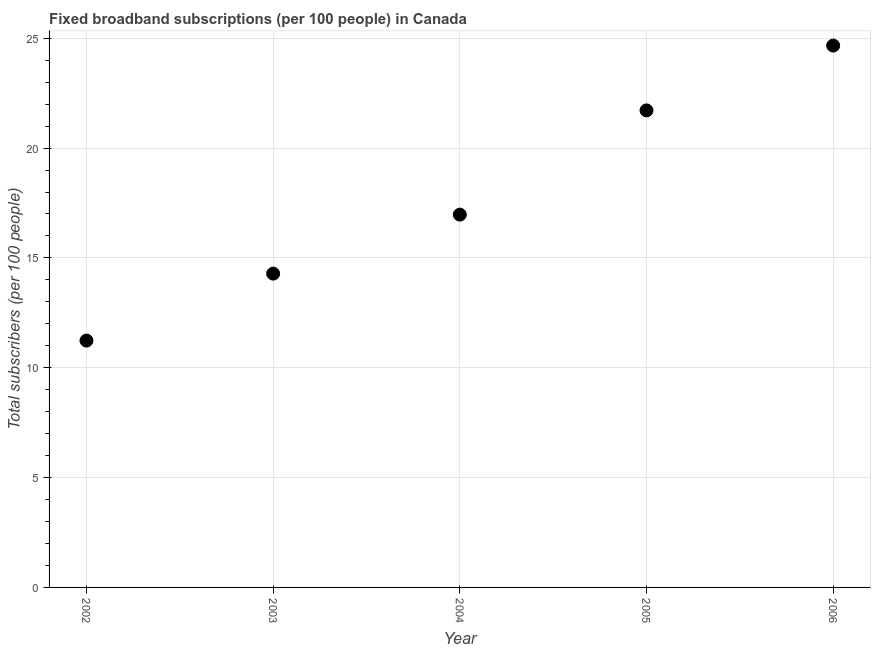What is the total number of fixed broadband subscriptions in 2003?
Your answer should be very brief. 14.29. Across all years, what is the maximum total number of fixed broadband subscriptions?
Keep it short and to the point. 24.67. Across all years, what is the minimum total number of fixed broadband subscriptions?
Offer a very short reply. 11.24. In which year was the total number of fixed broadband subscriptions maximum?
Offer a very short reply. 2006. What is the sum of the total number of fixed broadband subscriptions?
Make the answer very short. 88.87. What is the difference between the total number of fixed broadband subscriptions in 2002 and 2005?
Your answer should be compact. -10.48. What is the average total number of fixed broadband subscriptions per year?
Your response must be concise. 17.77. What is the median total number of fixed broadband subscriptions?
Provide a short and direct response. 16.97. Do a majority of the years between 2003 and 2005 (inclusive) have total number of fixed broadband subscriptions greater than 20 ?
Keep it short and to the point. No. What is the ratio of the total number of fixed broadband subscriptions in 2002 to that in 2003?
Your answer should be compact. 0.79. Is the total number of fixed broadband subscriptions in 2002 less than that in 2006?
Provide a short and direct response. Yes. Is the difference between the total number of fixed broadband subscriptions in 2002 and 2005 greater than the difference between any two years?
Give a very brief answer. No. What is the difference between the highest and the second highest total number of fixed broadband subscriptions?
Keep it short and to the point. 2.95. What is the difference between the highest and the lowest total number of fixed broadband subscriptions?
Offer a terse response. 13.43. In how many years, is the total number of fixed broadband subscriptions greater than the average total number of fixed broadband subscriptions taken over all years?
Offer a terse response. 2. Does the total number of fixed broadband subscriptions monotonically increase over the years?
Keep it short and to the point. Yes. How many years are there in the graph?
Make the answer very short. 5. What is the difference between two consecutive major ticks on the Y-axis?
Your answer should be very brief. 5. Are the values on the major ticks of Y-axis written in scientific E-notation?
Provide a short and direct response. No. Does the graph contain any zero values?
Offer a very short reply. No. Does the graph contain grids?
Your answer should be compact. Yes. What is the title of the graph?
Offer a terse response. Fixed broadband subscriptions (per 100 people) in Canada. What is the label or title of the Y-axis?
Your response must be concise. Total subscribers (per 100 people). What is the Total subscribers (per 100 people) in 2002?
Your response must be concise. 11.24. What is the Total subscribers (per 100 people) in 2003?
Provide a short and direct response. 14.29. What is the Total subscribers (per 100 people) in 2004?
Your answer should be very brief. 16.97. What is the Total subscribers (per 100 people) in 2005?
Provide a short and direct response. 21.72. What is the Total subscribers (per 100 people) in 2006?
Provide a succinct answer. 24.67. What is the difference between the Total subscribers (per 100 people) in 2002 and 2003?
Your response must be concise. -3.05. What is the difference between the Total subscribers (per 100 people) in 2002 and 2004?
Give a very brief answer. -5.73. What is the difference between the Total subscribers (per 100 people) in 2002 and 2005?
Offer a very short reply. -10.48. What is the difference between the Total subscribers (per 100 people) in 2002 and 2006?
Your answer should be compact. -13.43. What is the difference between the Total subscribers (per 100 people) in 2003 and 2004?
Your answer should be very brief. -2.69. What is the difference between the Total subscribers (per 100 people) in 2003 and 2005?
Keep it short and to the point. -7.43. What is the difference between the Total subscribers (per 100 people) in 2003 and 2006?
Provide a short and direct response. -10.38. What is the difference between the Total subscribers (per 100 people) in 2004 and 2005?
Your answer should be compact. -4.75. What is the difference between the Total subscribers (per 100 people) in 2004 and 2006?
Your answer should be very brief. -7.7. What is the difference between the Total subscribers (per 100 people) in 2005 and 2006?
Provide a short and direct response. -2.95. What is the ratio of the Total subscribers (per 100 people) in 2002 to that in 2003?
Offer a very short reply. 0.79. What is the ratio of the Total subscribers (per 100 people) in 2002 to that in 2004?
Offer a terse response. 0.66. What is the ratio of the Total subscribers (per 100 people) in 2002 to that in 2005?
Offer a very short reply. 0.52. What is the ratio of the Total subscribers (per 100 people) in 2002 to that in 2006?
Provide a succinct answer. 0.46. What is the ratio of the Total subscribers (per 100 people) in 2003 to that in 2004?
Offer a very short reply. 0.84. What is the ratio of the Total subscribers (per 100 people) in 2003 to that in 2005?
Provide a succinct answer. 0.66. What is the ratio of the Total subscribers (per 100 people) in 2003 to that in 2006?
Your answer should be very brief. 0.58. What is the ratio of the Total subscribers (per 100 people) in 2004 to that in 2005?
Ensure brevity in your answer.  0.78. What is the ratio of the Total subscribers (per 100 people) in 2004 to that in 2006?
Provide a short and direct response. 0.69. What is the ratio of the Total subscribers (per 100 people) in 2005 to that in 2006?
Give a very brief answer. 0.88. 